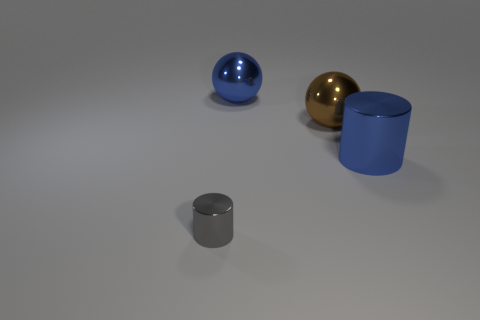Are there any small red blocks that have the same material as the big blue cylinder?
Provide a succinct answer. No. What shape is the thing that is both behind the large blue metallic cylinder and on the left side of the brown metal sphere?
Provide a short and direct response. Sphere. What number of small objects are blue things or gray metallic cylinders?
Your answer should be compact. 1. What is the material of the brown sphere?
Provide a succinct answer. Metal. How many other objects are there of the same shape as the gray thing?
Keep it short and to the point. 1. The brown object is what size?
Ensure brevity in your answer.  Large. What is the size of the object that is both to the left of the large brown sphere and behind the large blue cylinder?
Your response must be concise. Large. What is the shape of the metallic thing in front of the blue cylinder?
Your answer should be compact. Cylinder. Does the tiny gray cylinder have the same material as the large ball behind the brown shiny thing?
Offer a terse response. Yes. Is the gray thing the same shape as the brown metal object?
Provide a short and direct response. No. 